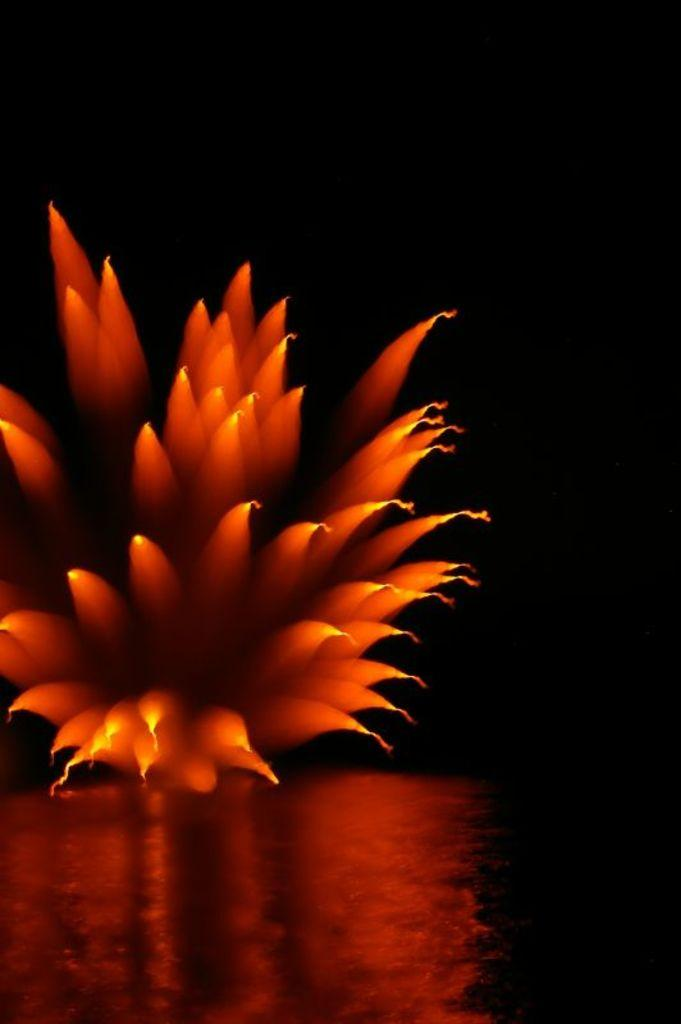What is the main subject in the foreground of the image? There is a flower in the foreground of the image. How would you describe the background of the image? The background of the image is dark. What can be seen at the bottom of the image? There is water visible at the bottom of the image. What type of comfort does the flower provide in the image? The image does not convey any information about the comfort provided by the flower. 